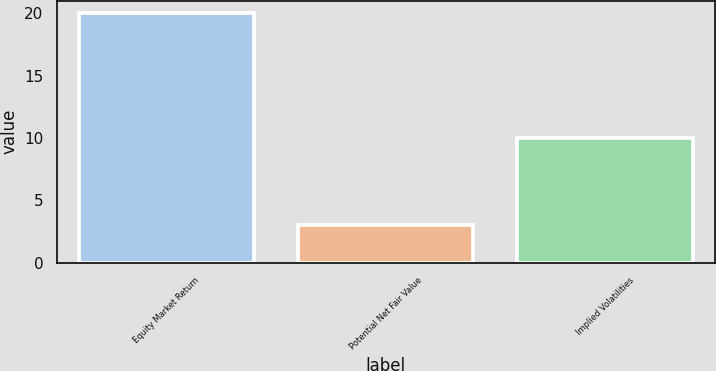Convert chart to OTSL. <chart><loc_0><loc_0><loc_500><loc_500><bar_chart><fcel>Equity Market Return<fcel>Potential Net Fair Value<fcel>Implied Volatilities<nl><fcel>20<fcel>3<fcel>10<nl></chart> 